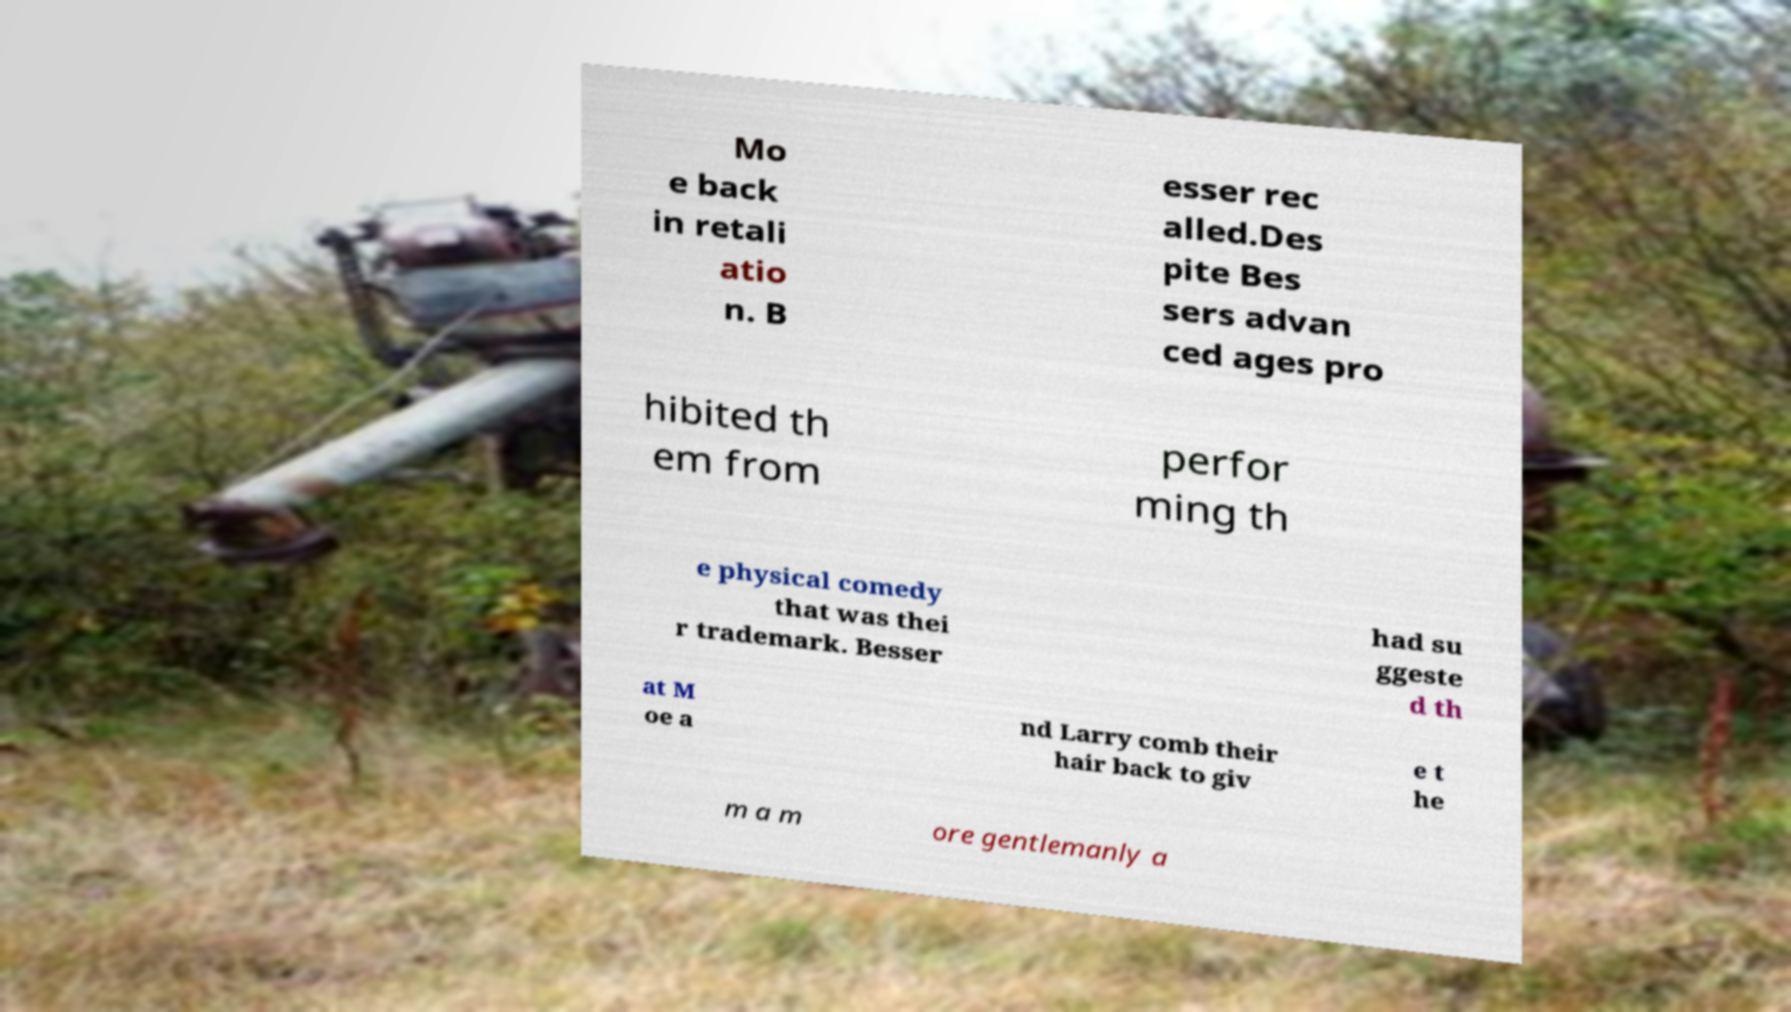There's text embedded in this image that I need extracted. Can you transcribe it verbatim? Mo e back in retali atio n. B esser rec alled.Des pite Bes sers advan ced ages pro hibited th em from perfor ming th e physical comedy that was thei r trademark. Besser had su ggeste d th at M oe a nd Larry comb their hair back to giv e t he m a m ore gentlemanly a 